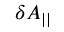Convert formula to latex. <formula><loc_0><loc_0><loc_500><loc_500>\delta A _ { | | }</formula> 